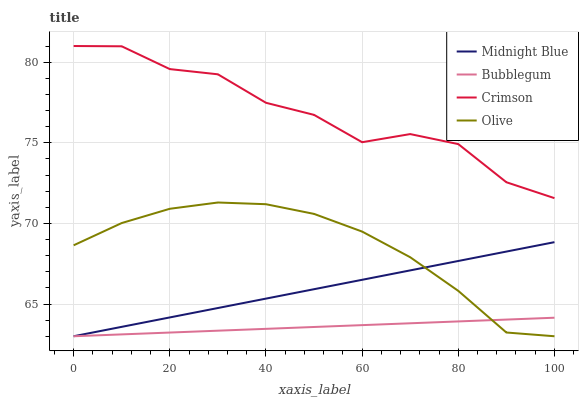Does Bubblegum have the minimum area under the curve?
Answer yes or no. Yes. Does Crimson have the maximum area under the curve?
Answer yes or no. Yes. Does Olive have the minimum area under the curve?
Answer yes or no. No. Does Olive have the maximum area under the curve?
Answer yes or no. No. Is Bubblegum the smoothest?
Answer yes or no. Yes. Is Crimson the roughest?
Answer yes or no. Yes. Is Olive the smoothest?
Answer yes or no. No. Is Olive the roughest?
Answer yes or no. No. Does Olive have the lowest value?
Answer yes or no. Yes. Does Crimson have the highest value?
Answer yes or no. Yes. Does Olive have the highest value?
Answer yes or no. No. Is Bubblegum less than Crimson?
Answer yes or no. Yes. Is Crimson greater than Olive?
Answer yes or no. Yes. Does Bubblegum intersect Olive?
Answer yes or no. Yes. Is Bubblegum less than Olive?
Answer yes or no. No. Is Bubblegum greater than Olive?
Answer yes or no. No. Does Bubblegum intersect Crimson?
Answer yes or no. No. 